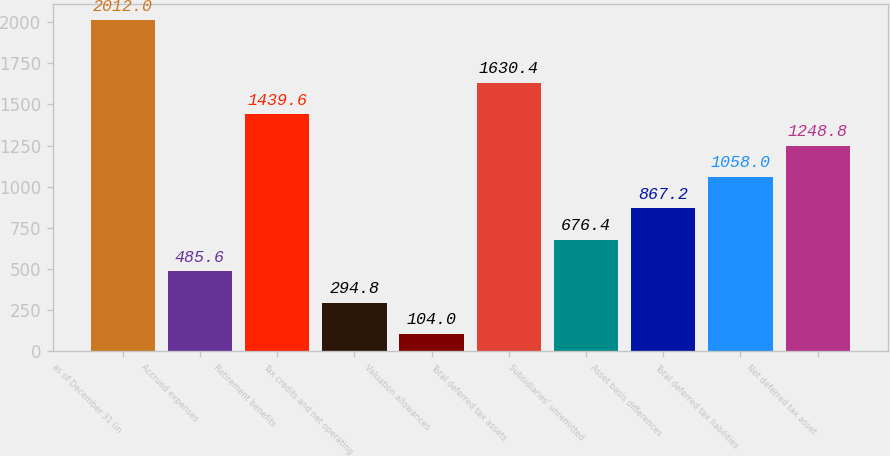Convert chart. <chart><loc_0><loc_0><loc_500><loc_500><bar_chart><fcel>as of December 31 (in<fcel>Accrued expenses<fcel>Retirement benefits<fcel>Tax credits and net operating<fcel>Valuation allowances<fcel>Total deferred tax assets<fcel>Subsidiaries' unremitted<fcel>Asset basis differences<fcel>Total deferred tax liabilities<fcel>Net deferred tax asset<nl><fcel>2012<fcel>485.6<fcel>1439.6<fcel>294.8<fcel>104<fcel>1630.4<fcel>676.4<fcel>867.2<fcel>1058<fcel>1248.8<nl></chart> 